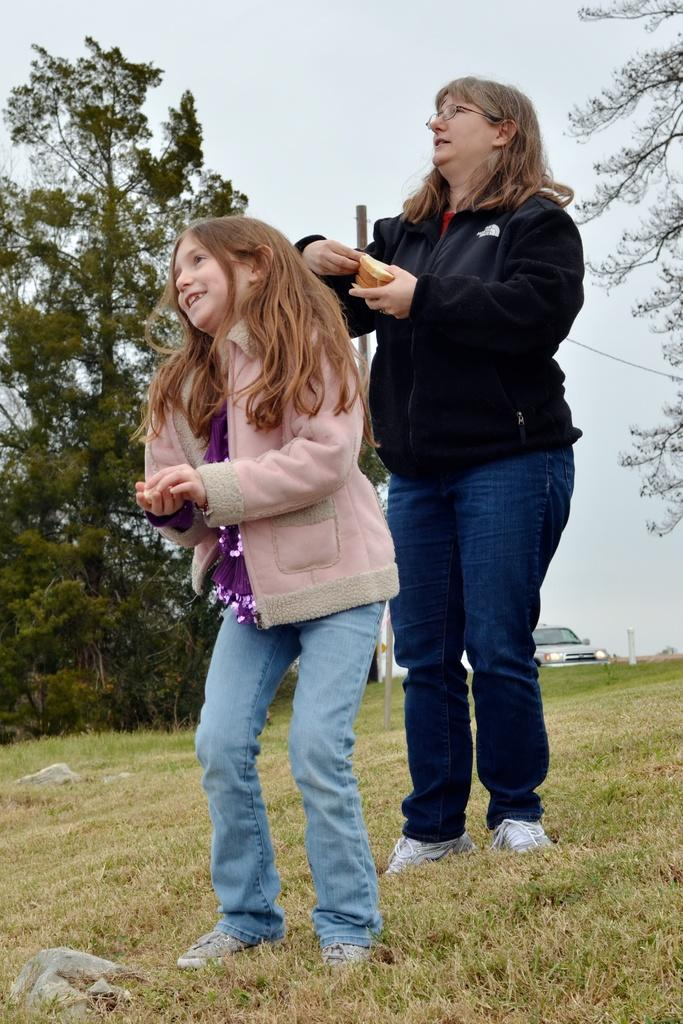Who are the main subjects in the image? There is a lady and a girl in the image. Where are they located in the image? They are in the center of the image. What is the setting of the image? They are on a grassland. What can be seen in the background of the image? There is a car and a tree in the background of the image. What type of bird is perched on the lady's shoulder in the image? There is no bird present in the image; the lady and the girl are the main subjects. 